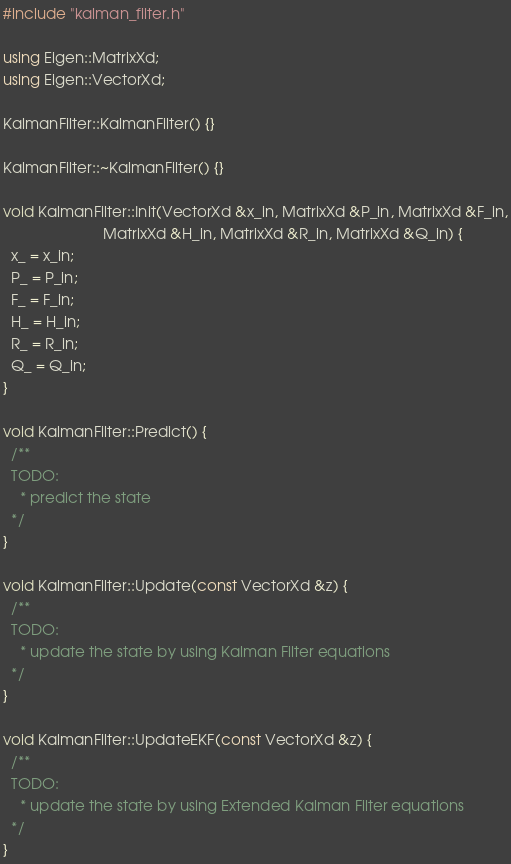<code> <loc_0><loc_0><loc_500><loc_500><_C++_>#include "kalman_filter.h"

using Eigen::MatrixXd;
using Eigen::VectorXd;

KalmanFilter::KalmanFilter() {}

KalmanFilter::~KalmanFilter() {}

void KalmanFilter::Init(VectorXd &x_in, MatrixXd &P_in, MatrixXd &F_in,
                        MatrixXd &H_in, MatrixXd &R_in, MatrixXd &Q_in) {
  x_ = x_in;
  P_ = P_in;
  F_ = F_in;
  H_ = H_in;
  R_ = R_in;
  Q_ = Q_in;
}

void KalmanFilter::Predict() {
  /**
  TODO:
    * predict the state
  */
}

void KalmanFilter::Update(const VectorXd &z) {
  /**
  TODO:
    * update the state by using Kalman Filter equations
  */
}

void KalmanFilter::UpdateEKF(const VectorXd &z) {
  /**
  TODO:
    * update the state by using Extended Kalman Filter equations
  */
}
</code> 